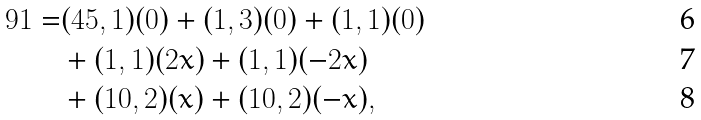Convert formula to latex. <formula><loc_0><loc_0><loc_500><loc_500>9 1 = & ( 4 5 , 1 ) ( 0 ) + ( 1 , 3 ) ( 0 ) + ( 1 , 1 ) ( 0 ) \\ & + ( 1 , 1 ) ( 2 x ) + ( 1 , 1 ) ( - 2 x ) \\ & + ( 1 0 , 2 ) ( x ) + ( 1 0 , 2 ) ( - x ) ,</formula> 